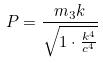Convert formula to latex. <formula><loc_0><loc_0><loc_500><loc_500>P = \frac { m _ { 3 } k } { \sqrt { 1 \cdot \frac { k ^ { 4 } } { c ^ { 4 } } } }</formula> 